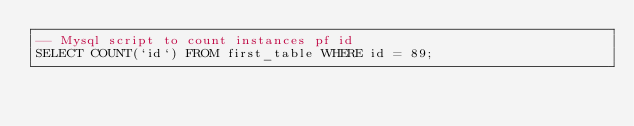Convert code to text. <code><loc_0><loc_0><loc_500><loc_500><_SQL_>-- Mysql script to count instances pf id
SELECT COUNT(`id`) FROM first_table WHERE id = 89;
</code> 